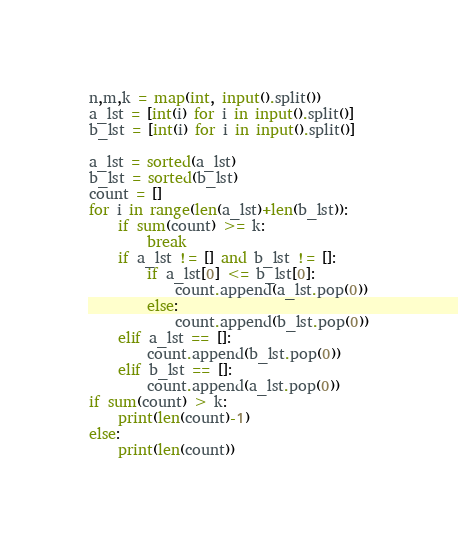Convert code to text. <code><loc_0><loc_0><loc_500><loc_500><_Python_>n,m,k = map(int, input().split())
a_lst = [int(i) for i in input().split()]
b_lst = [int(i) for i in input().split()]

a_lst = sorted(a_lst)
b_lst = sorted(b_lst)
count = []
for i in range(len(a_lst)+len(b_lst)):
    if sum(count) >= k:
        break
    if a_lst != [] and b_lst != []:
        if a_lst[0] <= b_lst[0]:
            count.append(a_lst.pop(0))
        else:
            count.append(b_lst.pop(0))
    elif a_lst == []:
        count.append(b_lst.pop(0))
    elif b_lst == []:
        count.append(a_lst.pop(0))
if sum(count) > k:
    print(len(count)-1)
else:
    print(len(count))</code> 